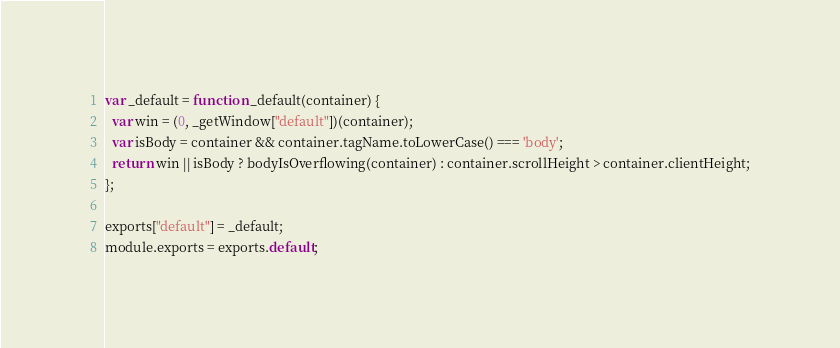Convert code to text. <code><loc_0><loc_0><loc_500><loc_500><_JavaScript_>
var _default = function _default(container) {
  var win = (0, _getWindow["default"])(container);
  var isBody = container && container.tagName.toLowerCase() === 'body';
  return win || isBody ? bodyIsOverflowing(container) : container.scrollHeight > container.clientHeight;
};

exports["default"] = _default;
module.exports = exports.default;</code> 